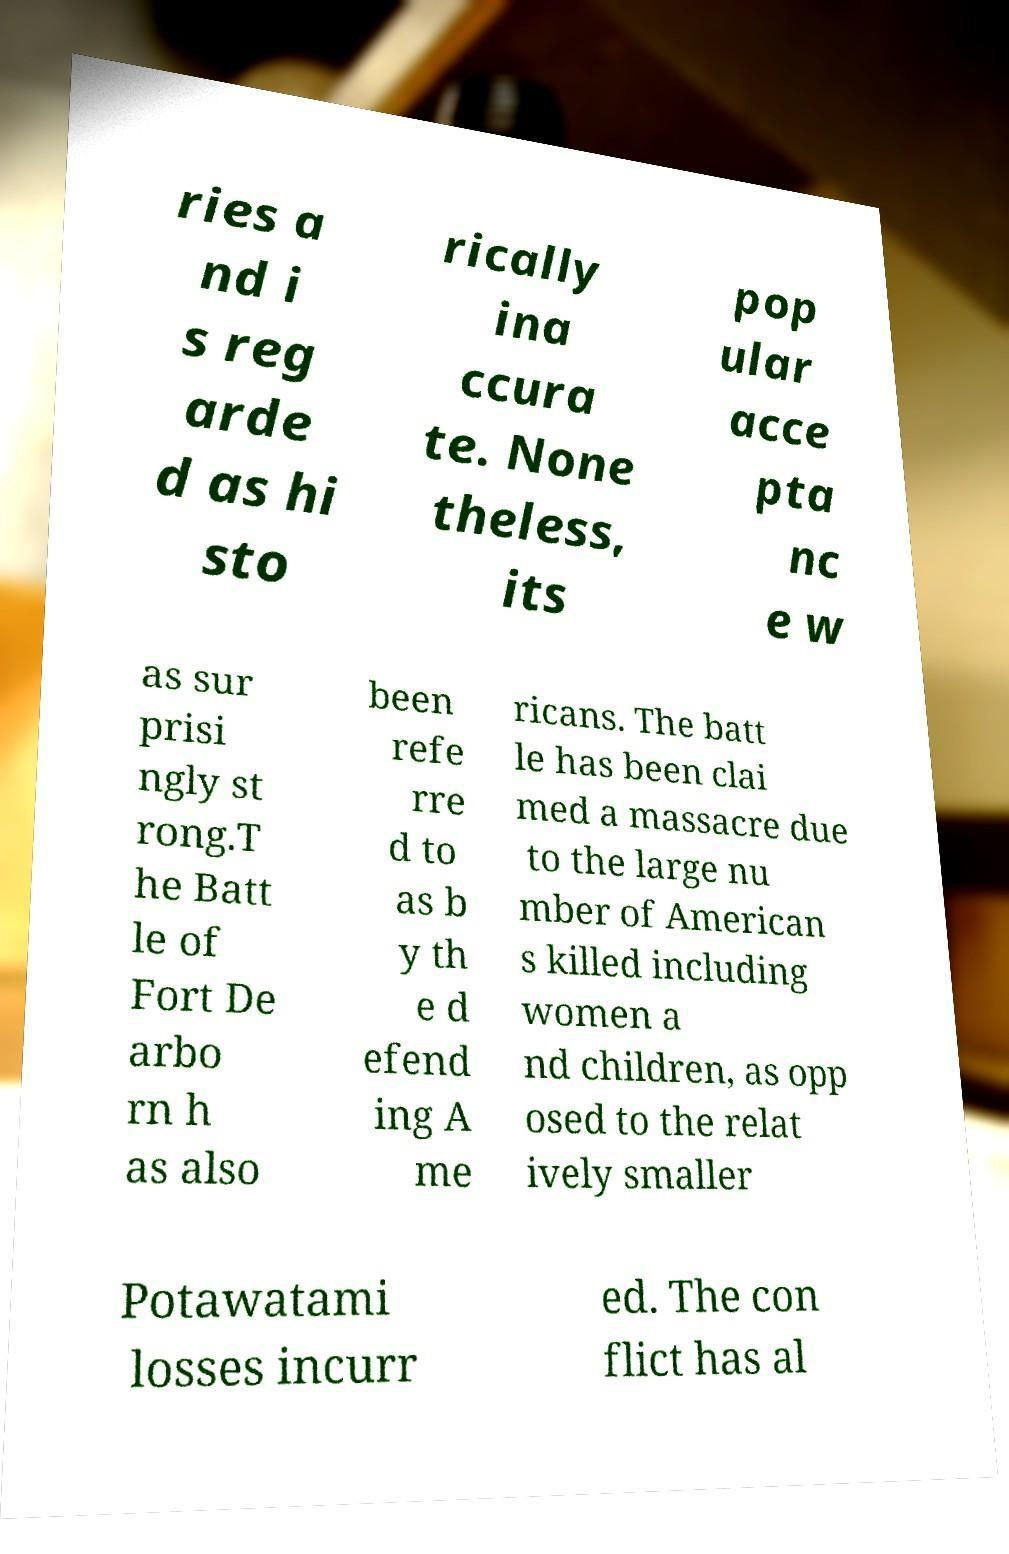Please read and relay the text visible in this image. What does it say? ries a nd i s reg arde d as hi sto rically ina ccura te. None theless, its pop ular acce pta nc e w as sur prisi ngly st rong.T he Batt le of Fort De arbo rn h as also been refe rre d to as b y th e d efend ing A me ricans. The batt le has been clai med a massacre due to the large nu mber of American s killed including women a nd children, as opp osed to the relat ively smaller Potawatami losses incurr ed. The con flict has al 